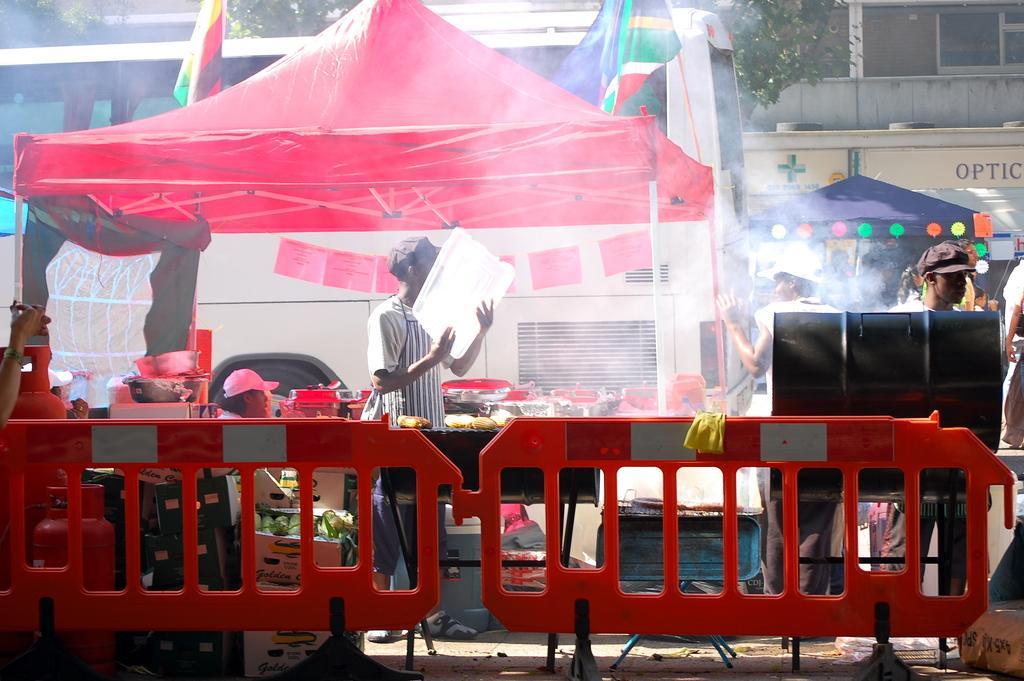Please provide a concise description of this image. In this picture we can see some people are under the tents, in which we can see some tables, boxes and we can see some vessels on the table. 